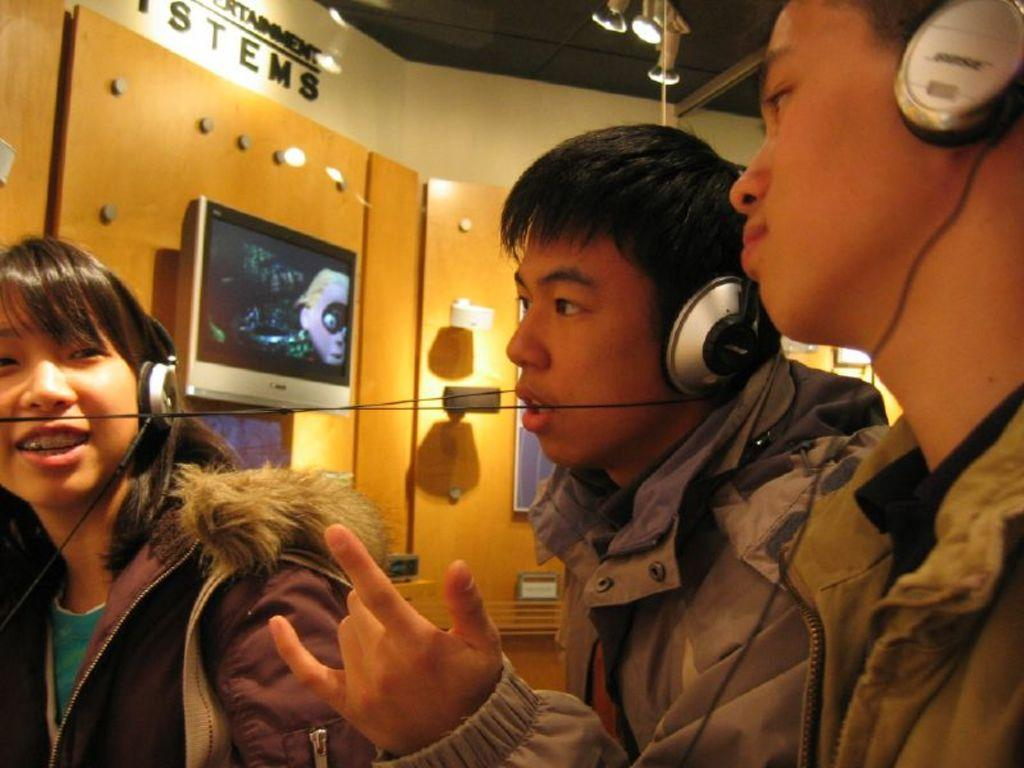How many people are in the image? There are three people in the image. What are the people wearing? The three people are wearing headsets. What can be seen in the background of the image? There is a wall, a television, and a light in the background of the image. Are there any lights visible at the top of the image? Yes, there are lights visible at the top of the image. What type of goldfish can be seen swimming in the image? There are no goldfish present in the image. What type of linen is draped over the television in the image? There is: There is no linen draped over the television in the image. 